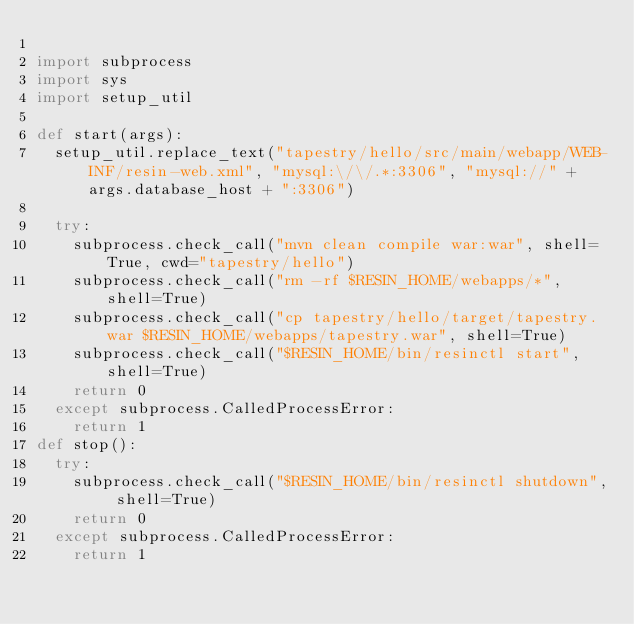Convert code to text. <code><loc_0><loc_0><loc_500><loc_500><_Python_>
import subprocess
import sys
import setup_util

def start(args):
  setup_util.replace_text("tapestry/hello/src/main/webapp/WEB-INF/resin-web.xml", "mysql:\/\/.*:3306", "mysql://" + args.database_host + ":3306")

  try:
    subprocess.check_call("mvn clean compile war:war", shell=True, cwd="tapestry/hello")
    subprocess.check_call("rm -rf $RESIN_HOME/webapps/*", shell=True)
    subprocess.check_call("cp tapestry/hello/target/tapestry.war $RESIN_HOME/webapps/tapestry.war", shell=True)
    subprocess.check_call("$RESIN_HOME/bin/resinctl start", shell=True)
    return 0
  except subprocess.CalledProcessError:
    return 1
def stop():
  try:
    subprocess.check_call("$RESIN_HOME/bin/resinctl shutdown", shell=True)
    return 0
  except subprocess.CalledProcessError:
    return 1</code> 